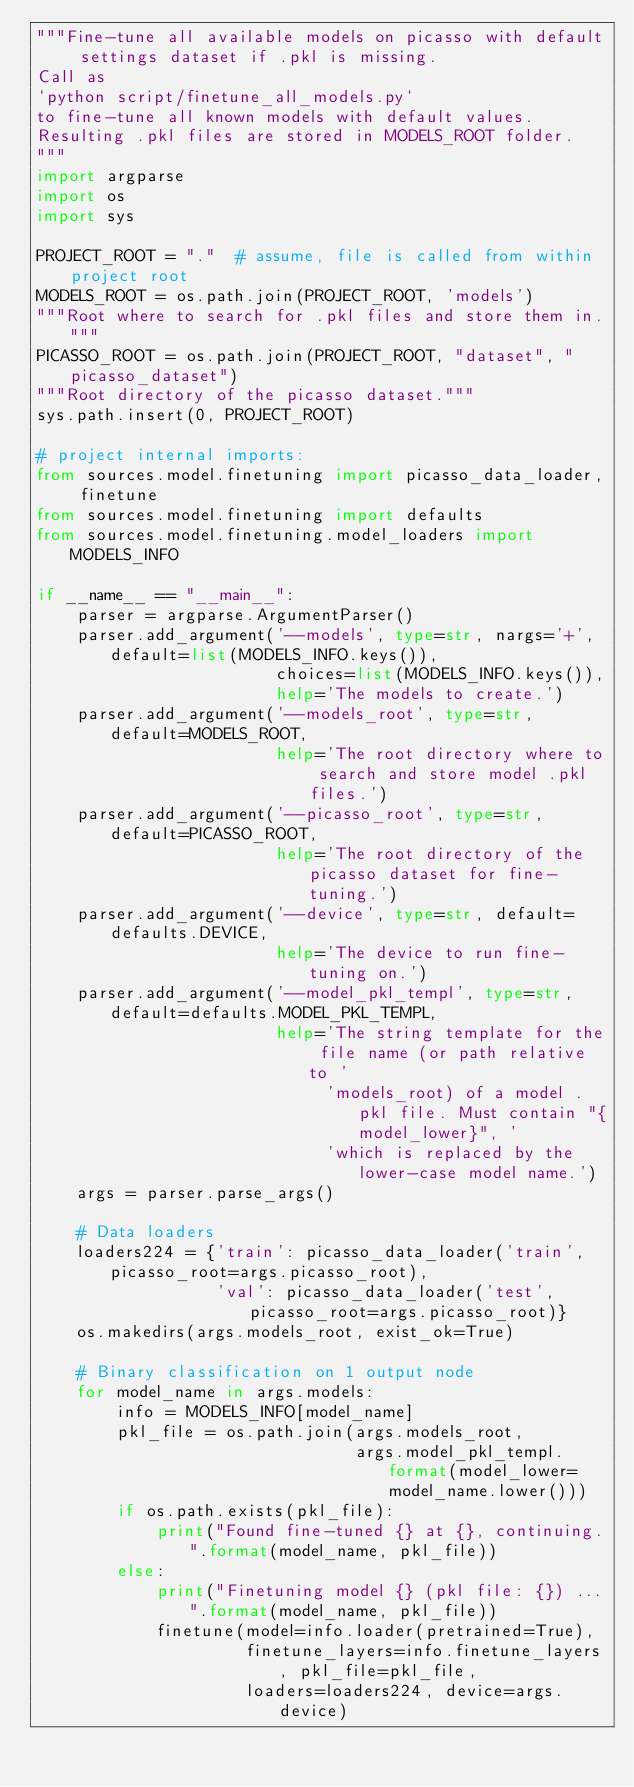Convert code to text. <code><loc_0><loc_0><loc_500><loc_500><_Python_>"""Fine-tune all available models on picasso with default settings dataset if .pkl is missing.
Call as
`python script/finetune_all_models.py`
to fine-tune all known models with default values.
Resulting .pkl files are stored in MODELS_ROOT folder.
"""
import argparse
import os
import sys

PROJECT_ROOT = "."  # assume, file is called from within project root
MODELS_ROOT = os.path.join(PROJECT_ROOT, 'models')
"""Root where to search for .pkl files and store them in."""
PICASSO_ROOT = os.path.join(PROJECT_ROOT, "dataset", "picasso_dataset")
"""Root directory of the picasso dataset."""
sys.path.insert(0, PROJECT_ROOT)

# project internal imports:
from sources.model.finetuning import picasso_data_loader, finetune
from sources.model.finetuning import defaults
from sources.model.finetuning.model_loaders import MODELS_INFO

if __name__ == "__main__":
    parser = argparse.ArgumentParser()
    parser.add_argument('--models', type=str, nargs='+', default=list(MODELS_INFO.keys()),
                        choices=list(MODELS_INFO.keys()),
                        help='The models to create.')
    parser.add_argument('--models_root', type=str, default=MODELS_ROOT,
                        help='The root directory where to search and store model .pkl files.')
    parser.add_argument('--picasso_root', type=str, default=PICASSO_ROOT,
                        help='The root directory of the picasso dataset for fine-tuning.')
    parser.add_argument('--device', type=str, default=defaults.DEVICE,
                        help='The device to run fine-tuning on.')
    parser.add_argument('--model_pkl_templ', type=str, default=defaults.MODEL_PKL_TEMPL,
                        help='The string template for the file name (or path relative to '
                             'models_root) of a model .pkl file. Must contain "{model_lower}", '
                             'which is replaced by the lower-case model name.')
    args = parser.parse_args()

    # Data loaders
    loaders224 = {'train': picasso_data_loader('train', picasso_root=args.picasso_root),
                  'val': picasso_data_loader('test', picasso_root=args.picasso_root)}
    os.makedirs(args.models_root, exist_ok=True)

    # Binary classification on 1 output node
    for model_name in args.models:
        info = MODELS_INFO[model_name]
        pkl_file = os.path.join(args.models_root,
                                args.model_pkl_templ.format(model_lower=model_name.lower()))
        if os.path.exists(pkl_file):
            print("Found fine-tuned {} at {}, continuing.".format(model_name, pkl_file))
        else:
            print("Finetuning model {} (pkl file: {}) ...".format(model_name, pkl_file))
            finetune(model=info.loader(pretrained=True),
                     finetune_layers=info.finetune_layers, pkl_file=pkl_file,
                     loaders=loaders224, device=args.device)
</code> 